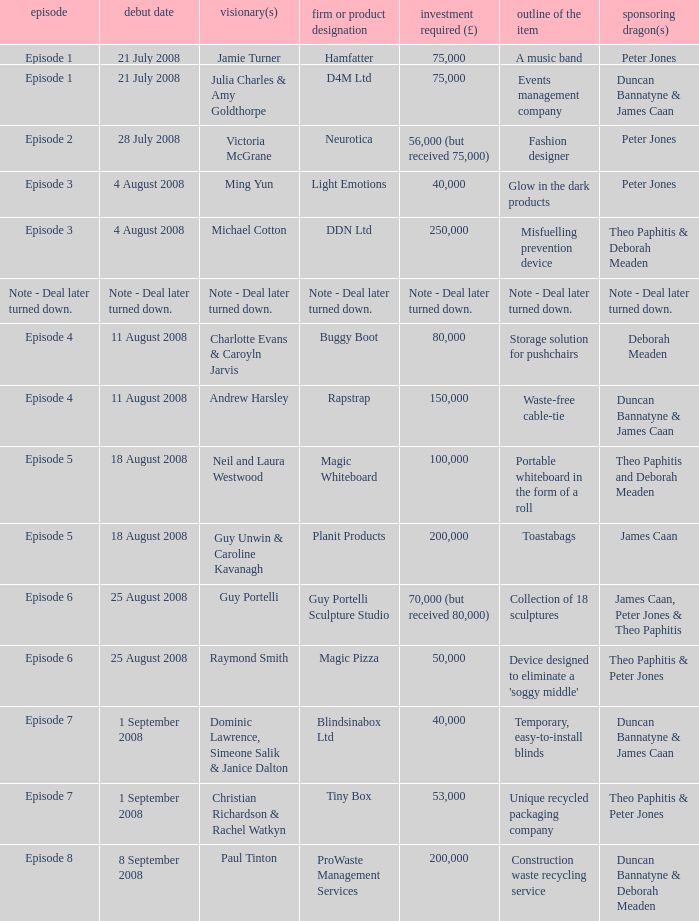How much money did the company Neurotica request? 56,000 (but received 75,000). 